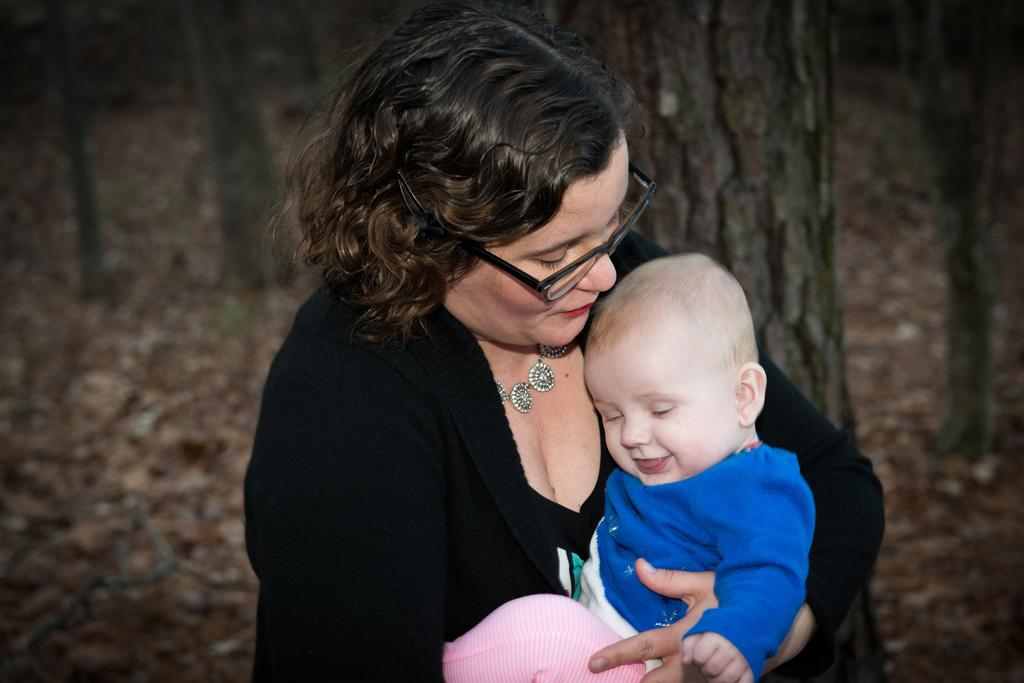Who is the main subject in the image? There is a woman in the image. What is the woman holding? The woman is holding a baby. What can be seen in the background of the image? There are trees and dried leaves on the ground in the background. How many children are playing with the pig in the image? There is no pig or children present in the image. 